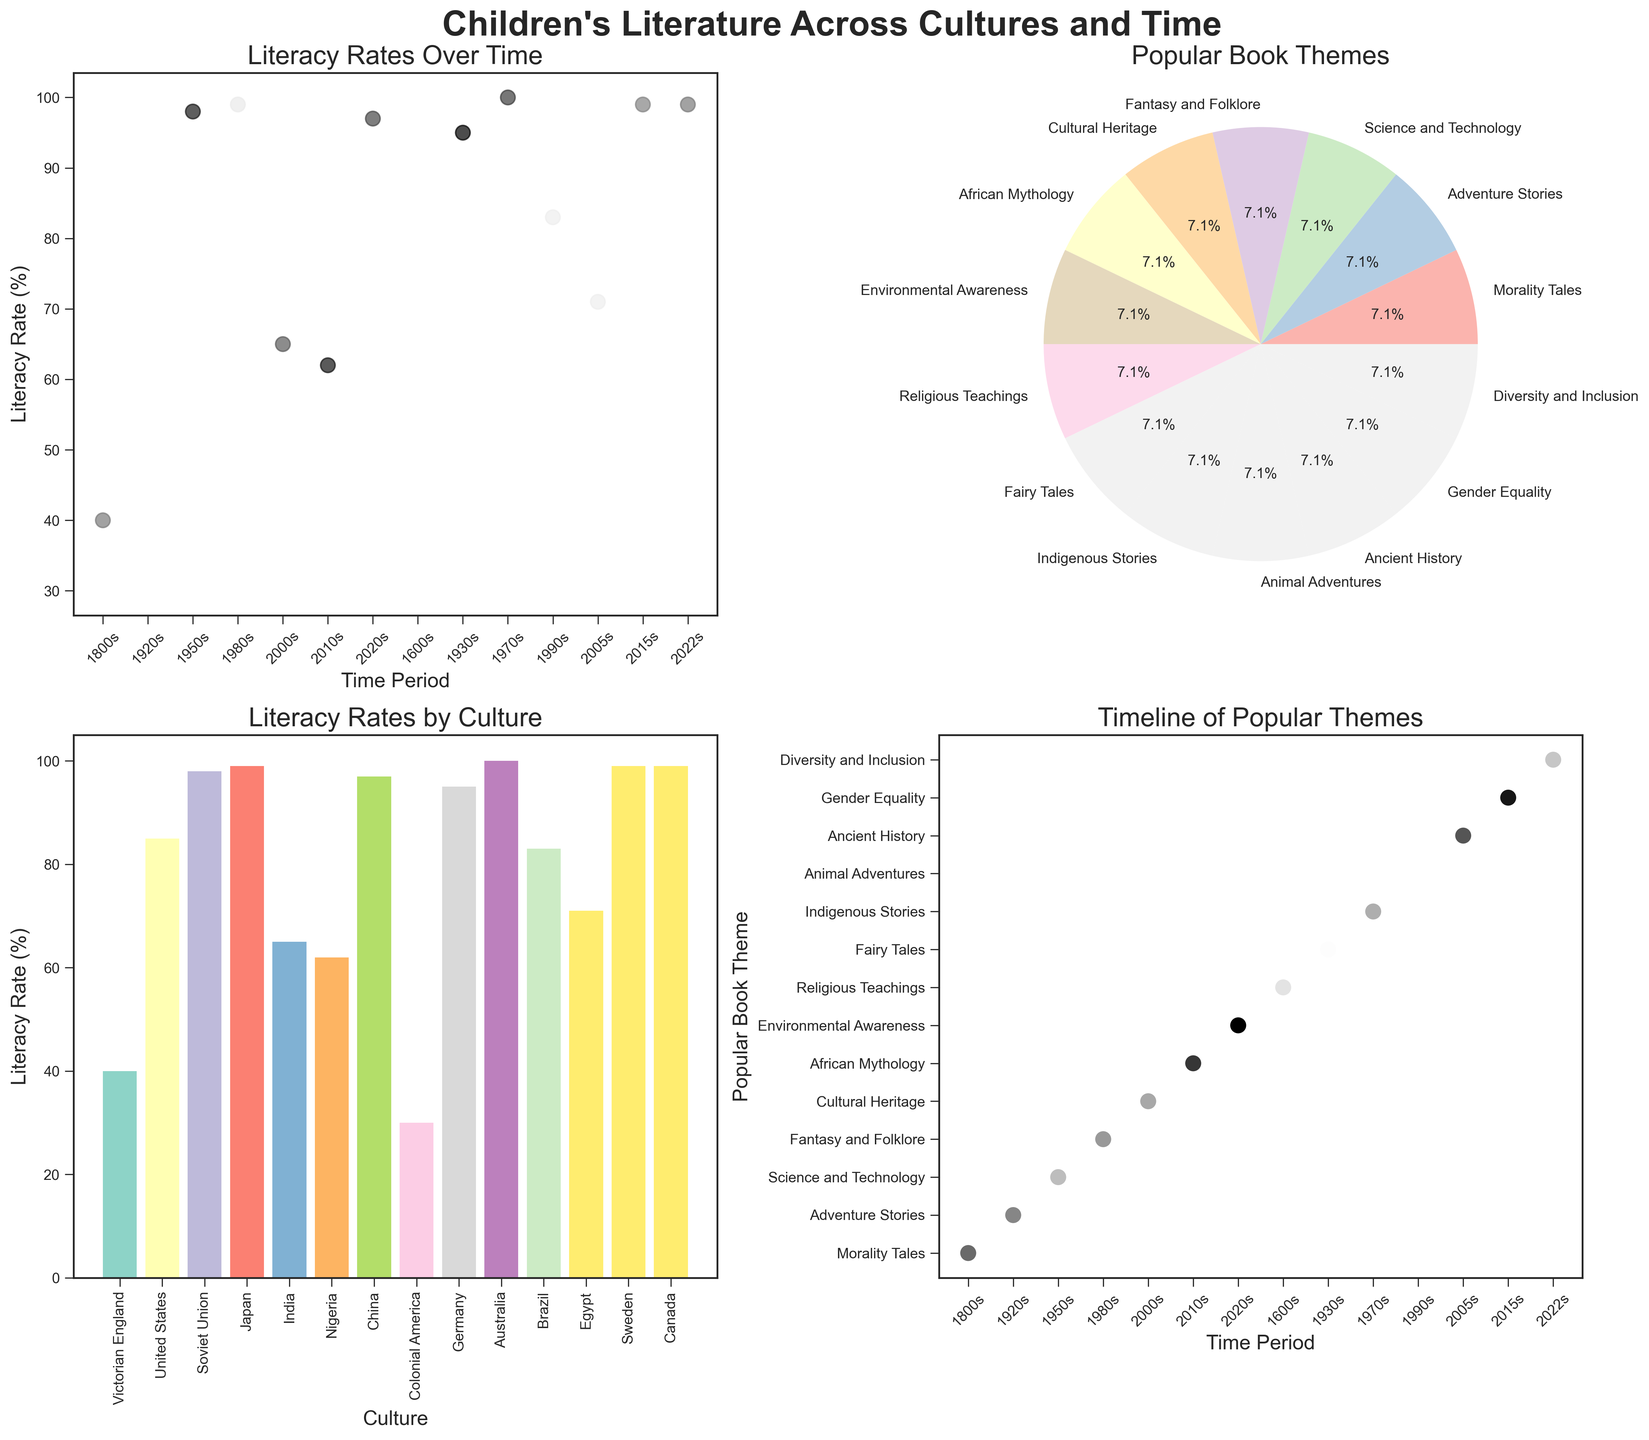What is the title of the overall figure? The title of the overall figure is located at the top center and states the main subject. It reads, "Children's Literature Across Cultures and Time."
Answer: Children's Literature Across Cultures and Time Which time period has the lowest literacy rate? By examining the first subplot "Literacy Rates Over Time," the earliest time period shown has the lowest literacy rate. The 1600s in Colonial America has a literacy rate of 30%.
Answer: 1600s What are the two popular book themes featured in the 1980s and 1990s? In the fourth subplot "Timeline of Popular Themes," locate the 1980s and 1990s on the x-axis. The associated themes for these periods are "Fantasy and Folklore" for the 1980s and "Animal Adventures" for the 1990s.
Answer: Fantasy and Folklore, Animal Adventures Which culture has the highest literacy rate? The third subplot "Literacy Rates by Culture" shows a bar chart of various cultures. Australia has a bar that reaches 100%, indicating it has the highest literacy rate.
Answer: Australia How many cultures have a literacy rate of 99%? In the third subplot, examine the bars reaching 99%. There are three cultures with a 99% literacy rate: Japan in the 1980s, Sweden in the 2015s, and Canada in the 2022s.
Answer: 3 What percentage of the popular book themes is represented by "Fantasy and Folklore"? The second subplot "Popular Book Themes" is a pie chart that shows the percentage distribution. "Fantasy and Folklore" can be identified in the pie chart, contributing a specific proportion. It is part of the chart and the exact percentage can be read directly.
Answer: 6.7% Compare the literacy rates of the United States in the 1920s and Brazil in the 1990s. Which is higher? In the first subplot "Literacy Rates Over Time," identify the literacy rates for the 1920s and 1990s. The United States in the 1920s has an 85% literacy rate, while Brazil in the 1990s has an 83% literacy rate. Therefore, the United States has a slightly higher rate.
Answer: United States During which time period did Germany have a common popular book theme of Fairy Tales? In the fourth subplot "Timeline of Popular Themes," finding Germany and observing the x-axis reveals that this occurred in the 1930s.
Answer: 1930s What is the range of literacy rates represented in the third subplot? In the subplot "Literacy Rates by Culture," the lowest bar reaches 30% and the highest reaches 100%. Thus, the range is the difference between these two values, which is 100% - 30% = 70%.
Answer: 70% 